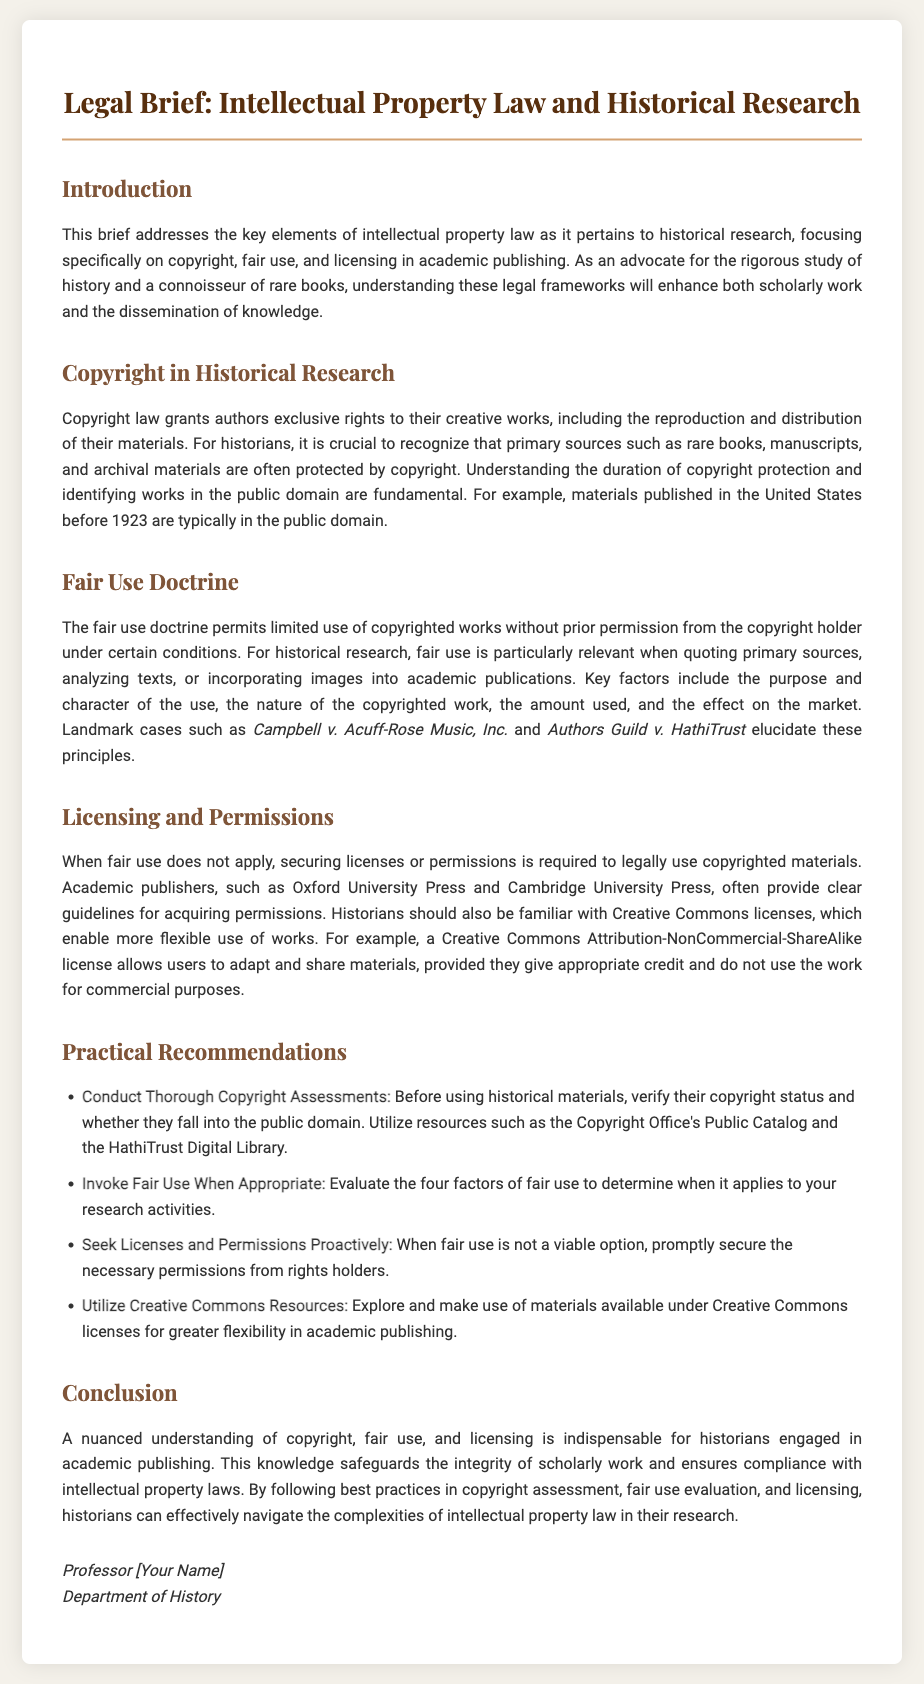What is the main focus of this legal brief? The main focus of the brief is on intellectual property law as it pertains to historical research, specifically copyright, fair use, and licensing in academic publishing.
Answer: Intellectual property law What year do works published in the United States typically enter the public domain? The document states that materials published in the United States before 1923 are typically in the public domain.
Answer: 1923 What is one key factor in the fair use doctrine? The document outlines several factors; one key factor is the purpose and character of the use.
Answer: Purpose and character Name one academic publisher mentioned in the document. The brief mentions academic publishers like Oxford University Press and Cambridge University Press.
Answer: Oxford University Press What type of license allows users to adapt and share materials non-commercially? The brief describes a Creative Commons Attribution-NonCommercial-ShareAlike license allowing such actions.
Answer: Creative Commons Attribution-NonCommercial-ShareAlike What is the first practical recommendation provided in the brief? The first recommendation emphasizes conducting thorough copyright assessments before using historical materials.
Answer: Conduct Thorough Copyright Assessments Which landmark case is mentioned in relation to fair use? The document refers to landmark cases such as Campbell v. Acuff-Rose Music, Inc. and Authors Guild v. HathiTrust.
Answer: Campbell v. Acuff-Rose Music, Inc What should historians utilize to verify copyright status? Historians should utilize resources like the Copyright Office's Public Catalog and the HathiTrust Digital Library to verify copyright status.
Answer: Copyright Office's Public Catalog In what context is fair use particularly relevant? Fair use is particularly relevant when quoting primary sources, analyzing texts, or incorporating images into academic publications.
Answer: Quoting primary sources 